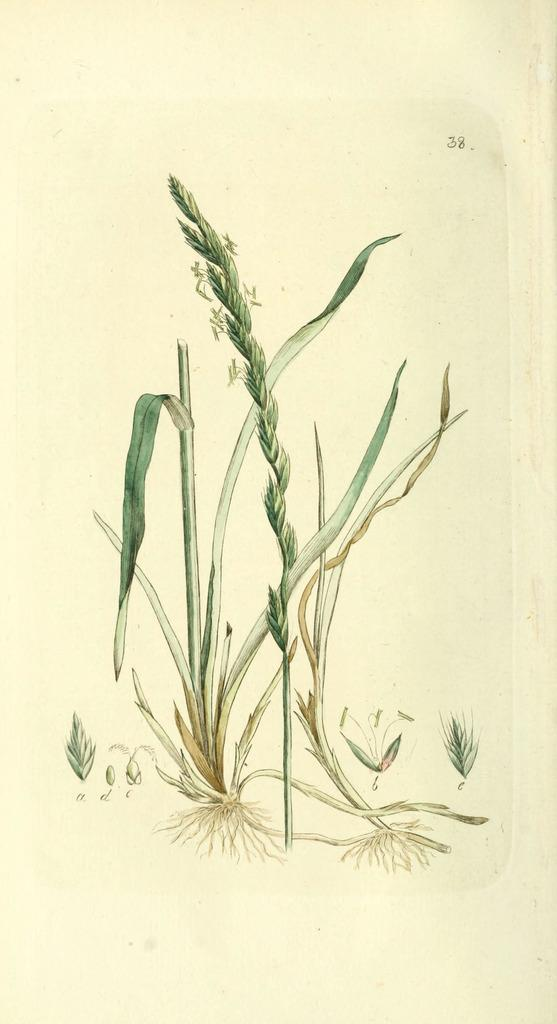What type of living organisms can be seen in the image? There are a few plants in the image. Is there any text or number visible in the image? Yes, there is a number in the top right corner of the image. What type of muscle can be seen flexing in the image? There is no muscle present in the image; it features plants and a number. What type of cracker is visible in the image? There is no cracker present in the image. 